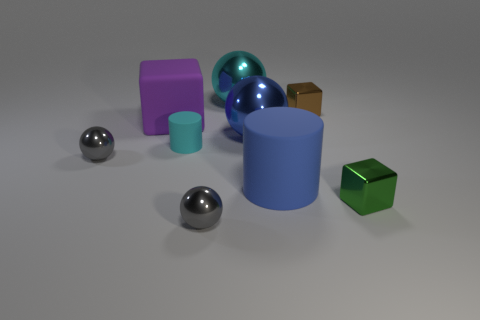How many other things are the same shape as the brown metal object?
Your answer should be very brief. 2. What color is the large ball in front of the purple thing?
Ensure brevity in your answer.  Blue. How many cyan cylinders are behind the tiny gray object that is behind the large matte thing that is in front of the blue shiny ball?
Offer a very short reply. 1. What number of cyan shiny things are behind the large cyan shiny thing that is right of the tiny cyan matte object?
Your response must be concise. 0. There is a brown object; how many things are on the left side of it?
Your response must be concise. 7. How many other objects are the same size as the cyan rubber thing?
Make the answer very short. 4. There is another matte thing that is the same shape as the blue rubber object; what size is it?
Your answer should be very brief. Small. There is a metallic object on the right side of the tiny brown thing; what is its shape?
Provide a short and direct response. Cube. The large rubber object on the right side of the shiny ball in front of the blue cylinder is what color?
Your answer should be compact. Blue. What number of objects are either small shiny cubes behind the blue cylinder or big blue cylinders?
Your response must be concise. 2. 